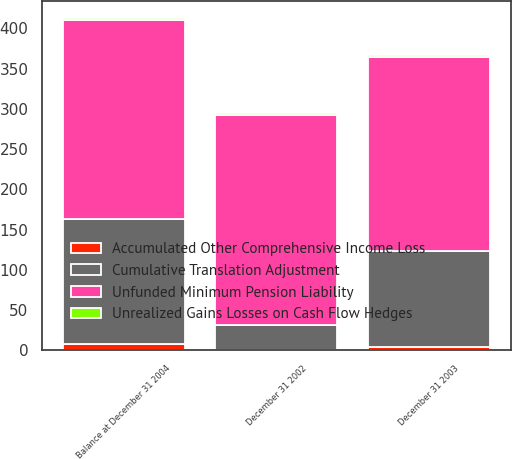Convert chart. <chart><loc_0><loc_0><loc_500><loc_500><stacked_bar_chart><ecel><fcel>December 31 2002<fcel>December 31 2003<fcel>Balance at December 31 2004<nl><fcel>Cumulative Translation Adjustment<fcel>31<fcel>119<fcel>155<nl><fcel>Unfunded Minimum Pension Liability<fcel>261<fcel>242<fcel>248<nl><fcel>Accumulated Other Comprehensive Income Loss<fcel>1<fcel>4<fcel>8<nl><fcel>Unrealized Gains Losses on Cash Flow Hedges<fcel>2<fcel>2<fcel>2<nl></chart> 